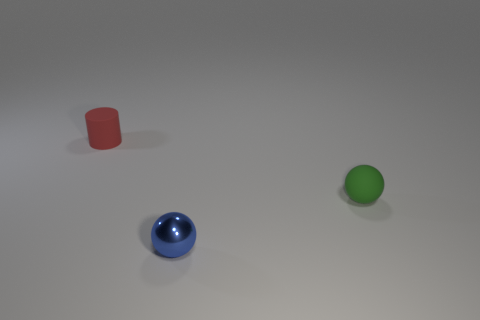Do the objects appear as though they could be part of a game? While the objects are not recognizable as part of a traditional game, their varied shapes and colors could suggest elements of an abstract or educational game, designed for sorting or matching exercises. 